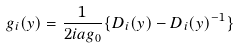Convert formula to latex. <formula><loc_0><loc_0><loc_500><loc_500>g _ { i } ( { y } ) = \frac { 1 } { 2 i a g _ { 0 } } \{ D _ { i } ( { y } ) - D _ { i } ( { y } ) ^ { - 1 } \}</formula> 